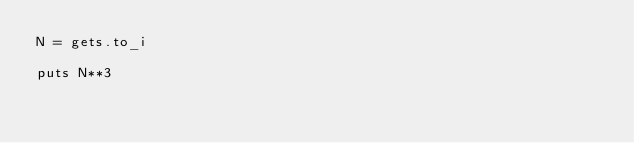Convert code to text. <code><loc_0><loc_0><loc_500><loc_500><_Ruby_>N = gets.to_i

puts N**3
</code> 